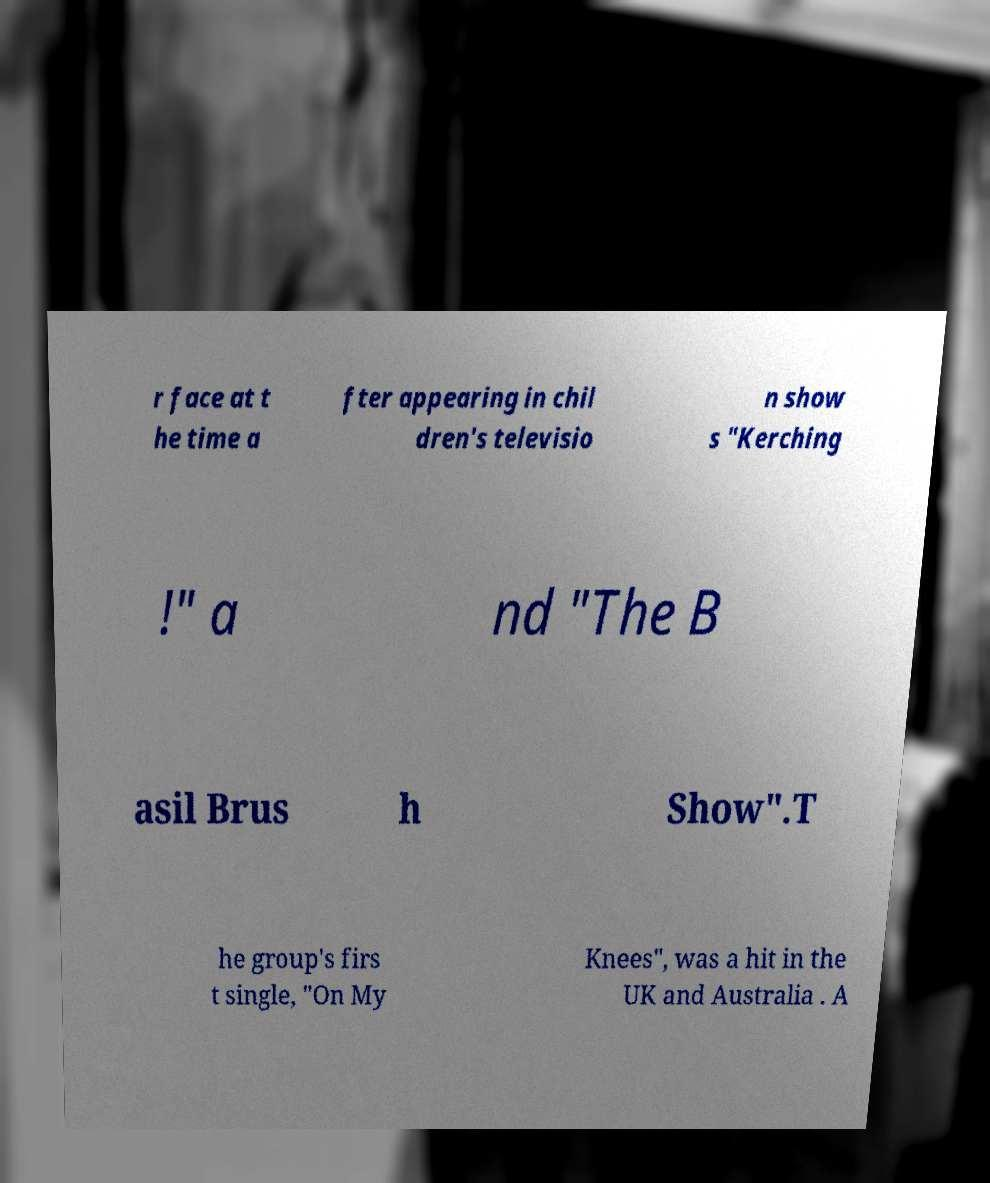For documentation purposes, I need the text within this image transcribed. Could you provide that? r face at t he time a fter appearing in chil dren's televisio n show s "Kerching !" a nd "The B asil Brus h Show".T he group's firs t single, "On My Knees", was a hit in the UK and Australia . A 